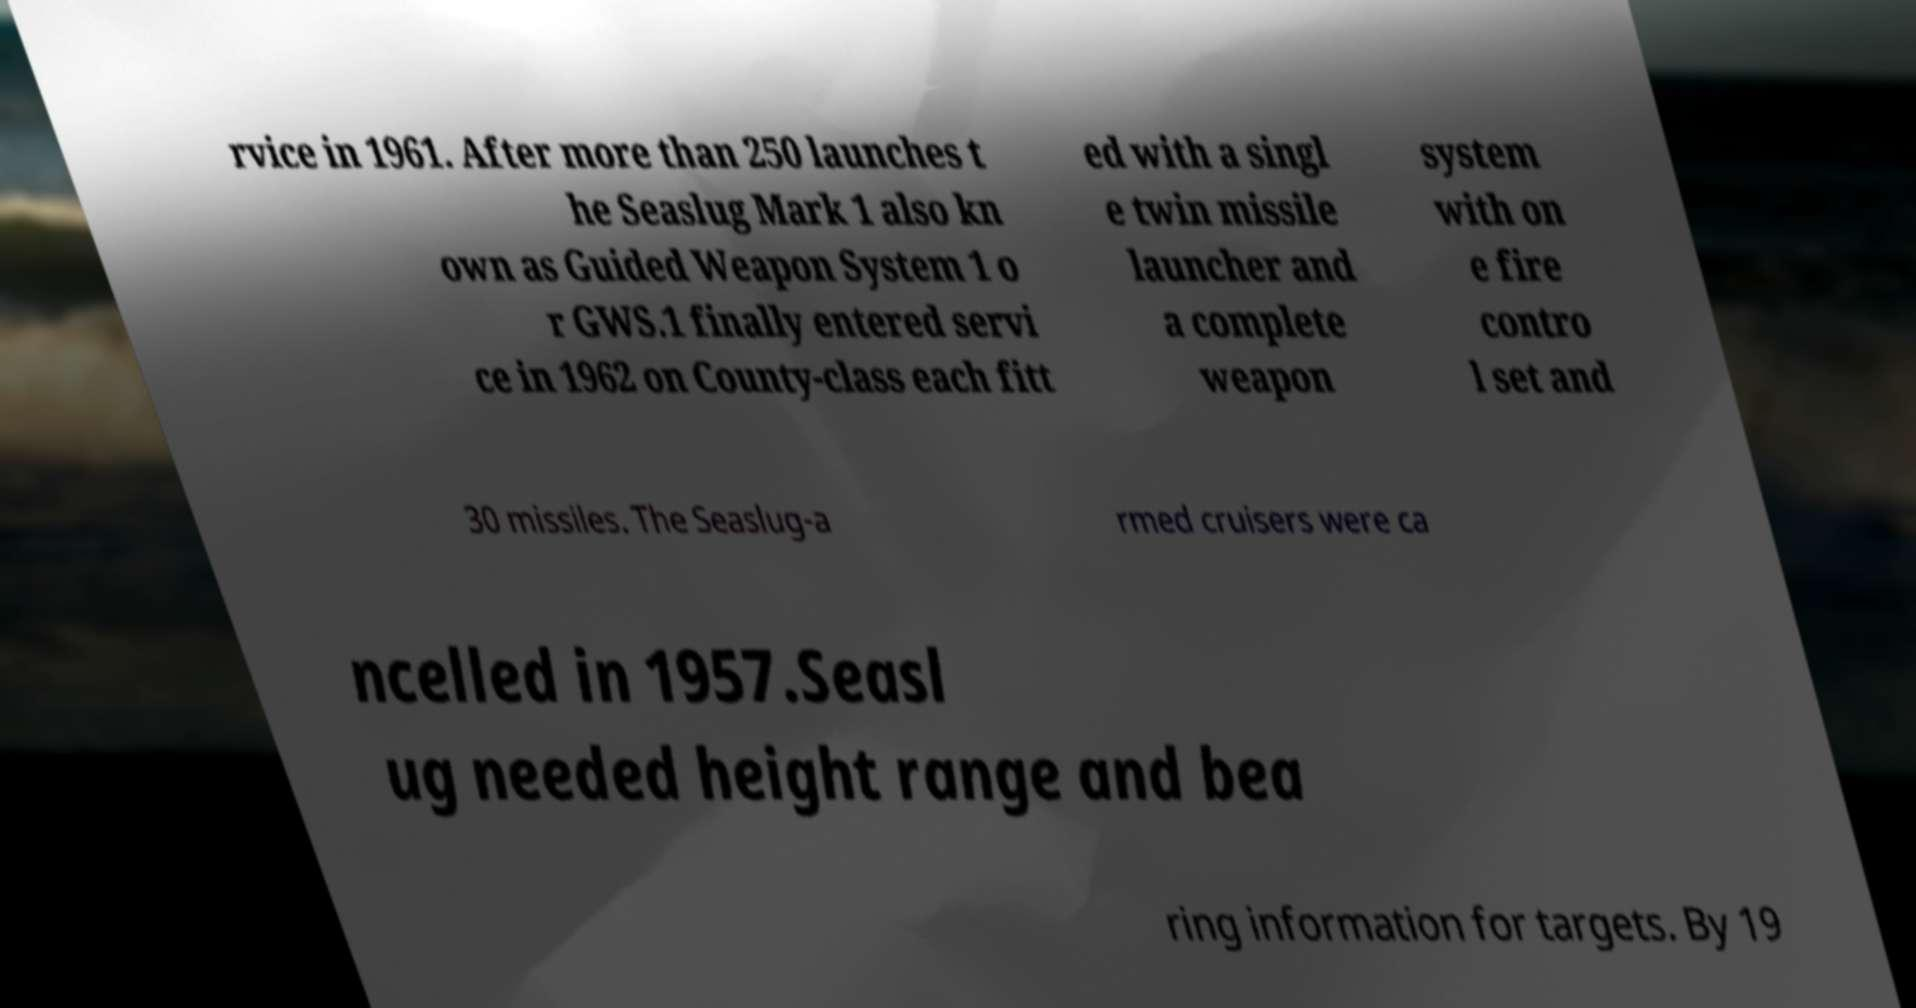There's text embedded in this image that I need extracted. Can you transcribe it verbatim? rvice in 1961. After more than 250 launches t he Seaslug Mark 1 also kn own as Guided Weapon System 1 o r GWS.1 finally entered servi ce in 1962 on County-class each fitt ed with a singl e twin missile launcher and a complete weapon system with on e fire contro l set and 30 missiles. The Seaslug-a rmed cruisers were ca ncelled in 1957.Seasl ug needed height range and bea ring information for targets. By 19 